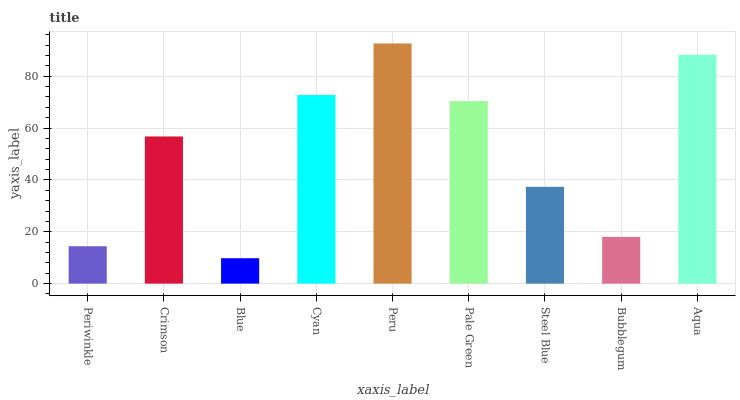Is Crimson the minimum?
Answer yes or no. No. Is Crimson the maximum?
Answer yes or no. No. Is Crimson greater than Periwinkle?
Answer yes or no. Yes. Is Periwinkle less than Crimson?
Answer yes or no. Yes. Is Periwinkle greater than Crimson?
Answer yes or no. No. Is Crimson less than Periwinkle?
Answer yes or no. No. Is Crimson the high median?
Answer yes or no. Yes. Is Crimson the low median?
Answer yes or no. Yes. Is Blue the high median?
Answer yes or no. No. Is Bubblegum the low median?
Answer yes or no. No. 